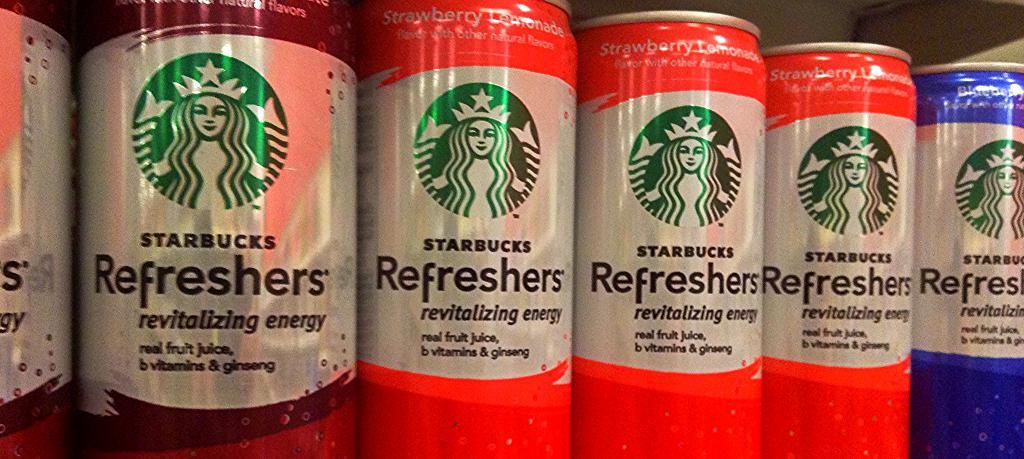<image>
Describe the image concisely. several cans of drinks with the words starbucks refreshers on them. 